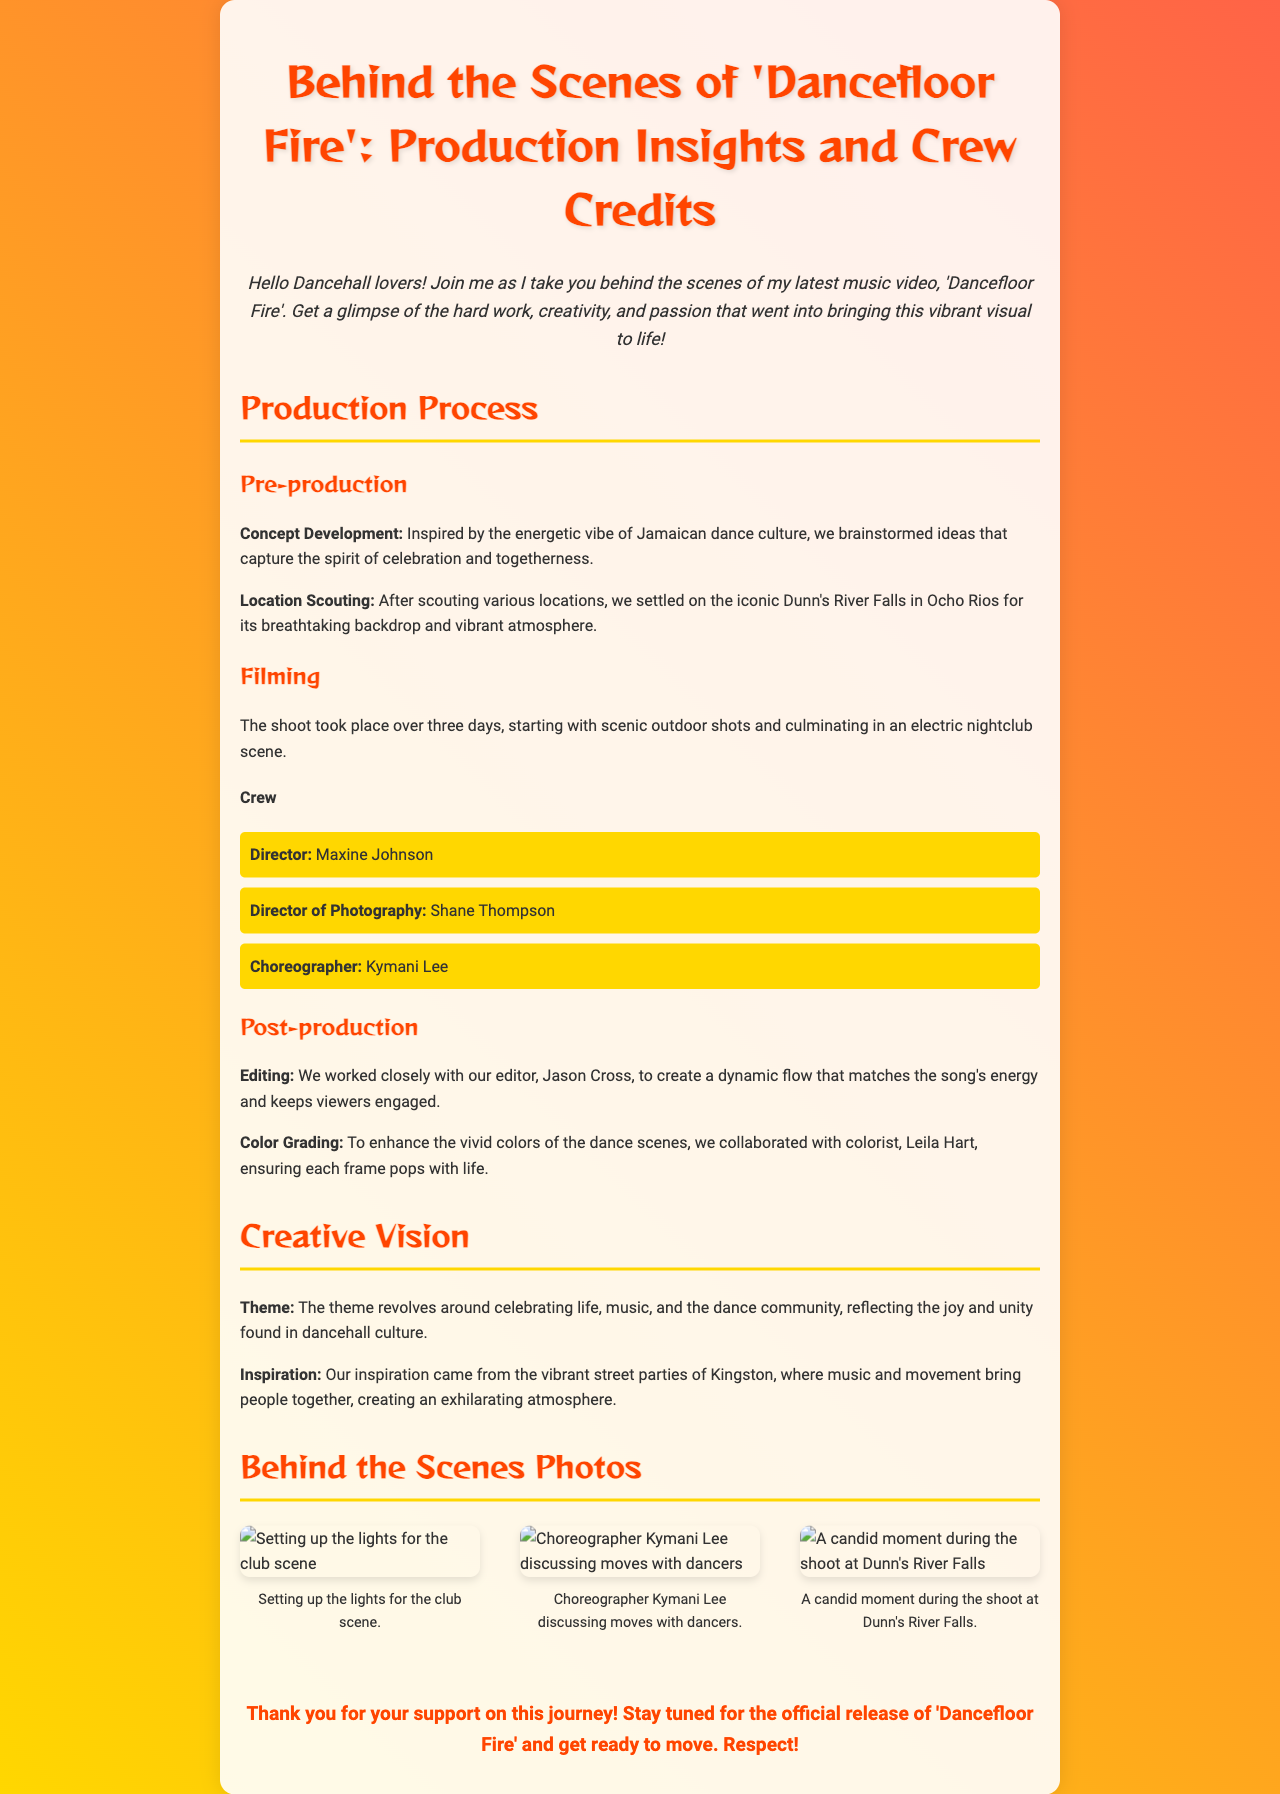What is the title of the music video? The title of the music video is mentioned in the document as 'Dancefloor Fire'.
Answer: Dancefloor Fire Who was the Director of Photography? The role of Director of Photography is credited to Shane Thompson in the crew list.
Answer: Shane Thompson What location was chosen for the shoot? The document states that the location chosen for the shoot was Dunn's River Falls in Ocho Rios.
Answer: Dunn's River Falls How many days did the filming take place? The document indicates that the filming took place over three days.
Answer: Three days What is the main theme of the music video? The document outlines that the main theme revolves around celebrating life, music, and the dance community.
Answer: Celebrating life, music, and the dance community Who edited the music video? According to the document, the video was edited by Jason Cross.
Answer: Jason Cross What inspired the creative vision of the video? The inspiration came from vibrant street parties of Kingston, where music and movement bring people together.
Answer: Vibrant street parties of Kingston What type of content does the photo gallery contain? The photo gallery contains behind-the-scenes photos showing various aspects of the production process.
Answer: Behind-the-scenes photos 